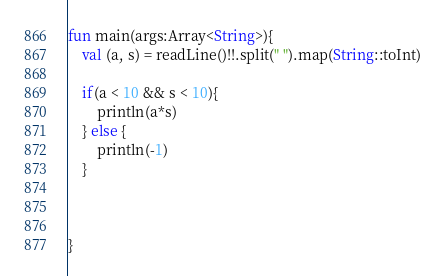<code> <loc_0><loc_0><loc_500><loc_500><_Kotlin_>fun main(args:Array<String>){
	val (a, s) = readLine()!!.split(" ").map(String::toInt)
    
    if(a < 10 && s < 10){
        println(a*s)
    } else {
        println(-1)
    }
    


}</code> 